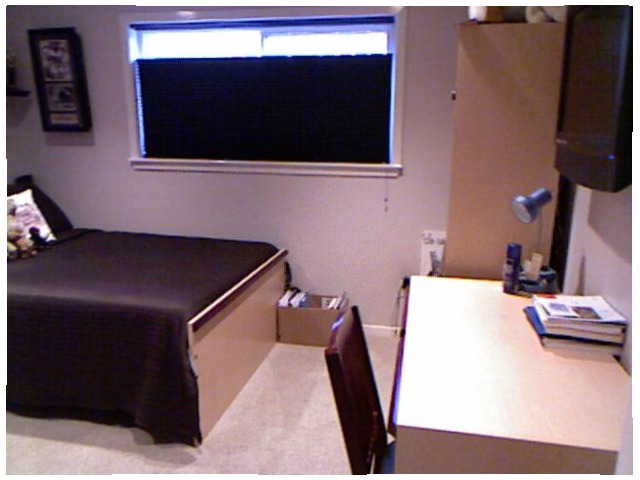<image>
Can you confirm if the books is on the table? Yes. Looking at the image, I can see the books is positioned on top of the table, with the table providing support. 